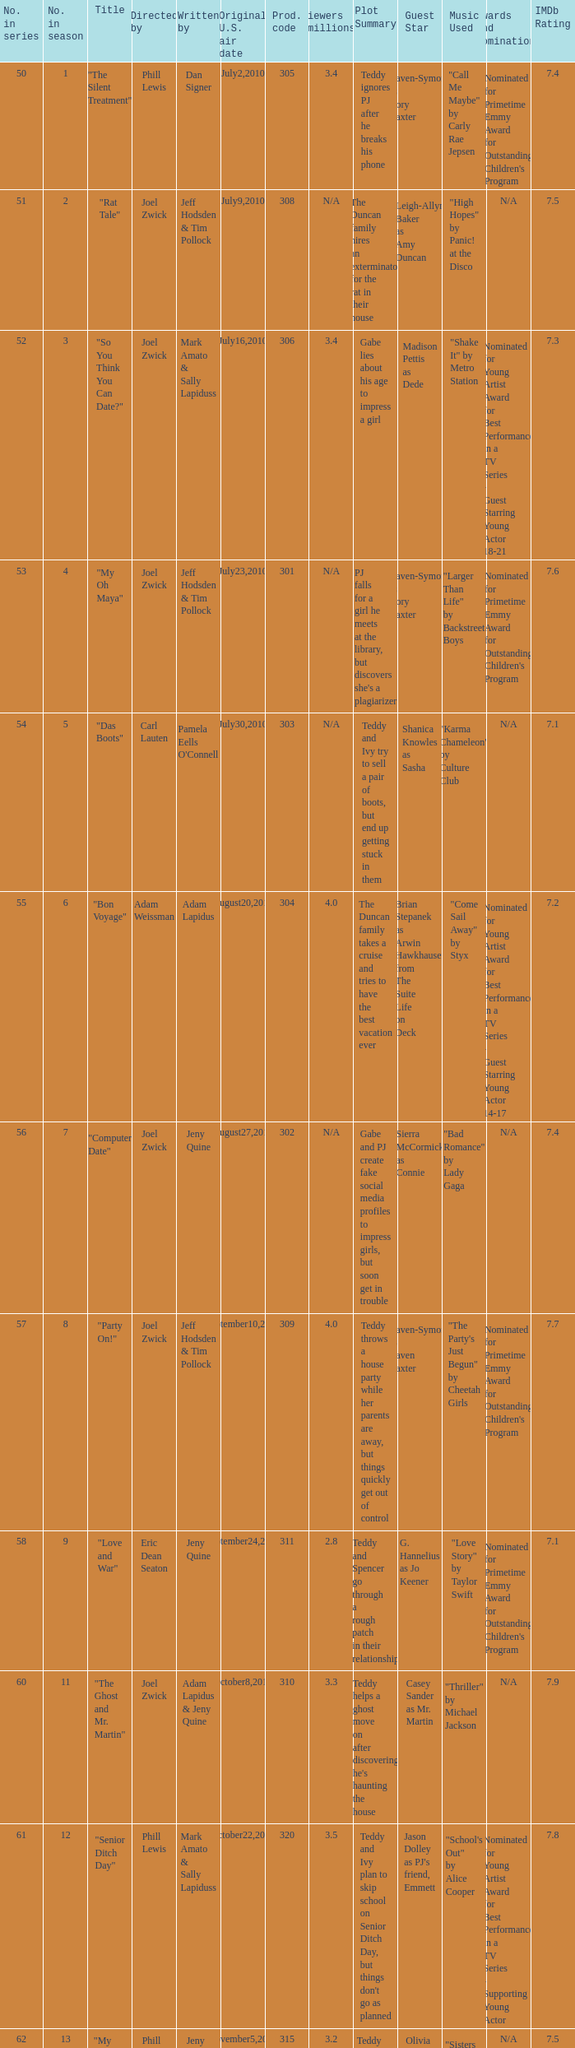Who was the directed for the episode titled "twister: part 1"? Bob Koherr. 